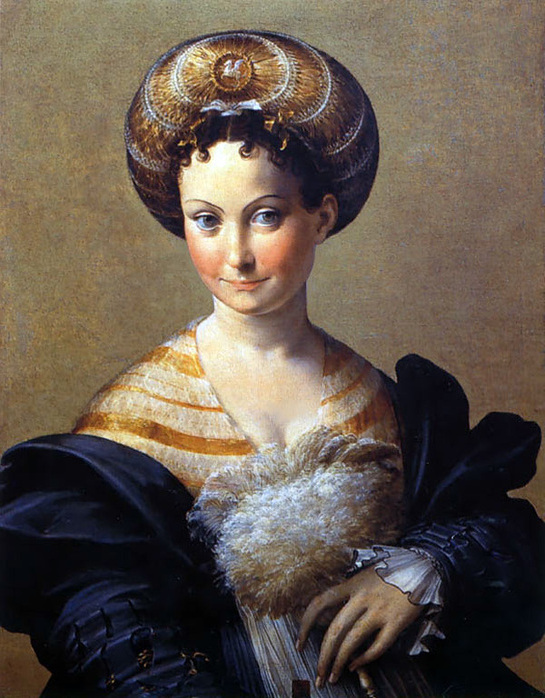What can you tell about the social status of the person depicted in this painting? The woman in the painting likely holds a high social status, evident from her luxurious attire. The fur collar and the headdress adorned with gold and pearls signify wealth and nobility during the Renaissance. Such elaborate clothing and expensive materials were typically reserved for the upper echelons of society. 